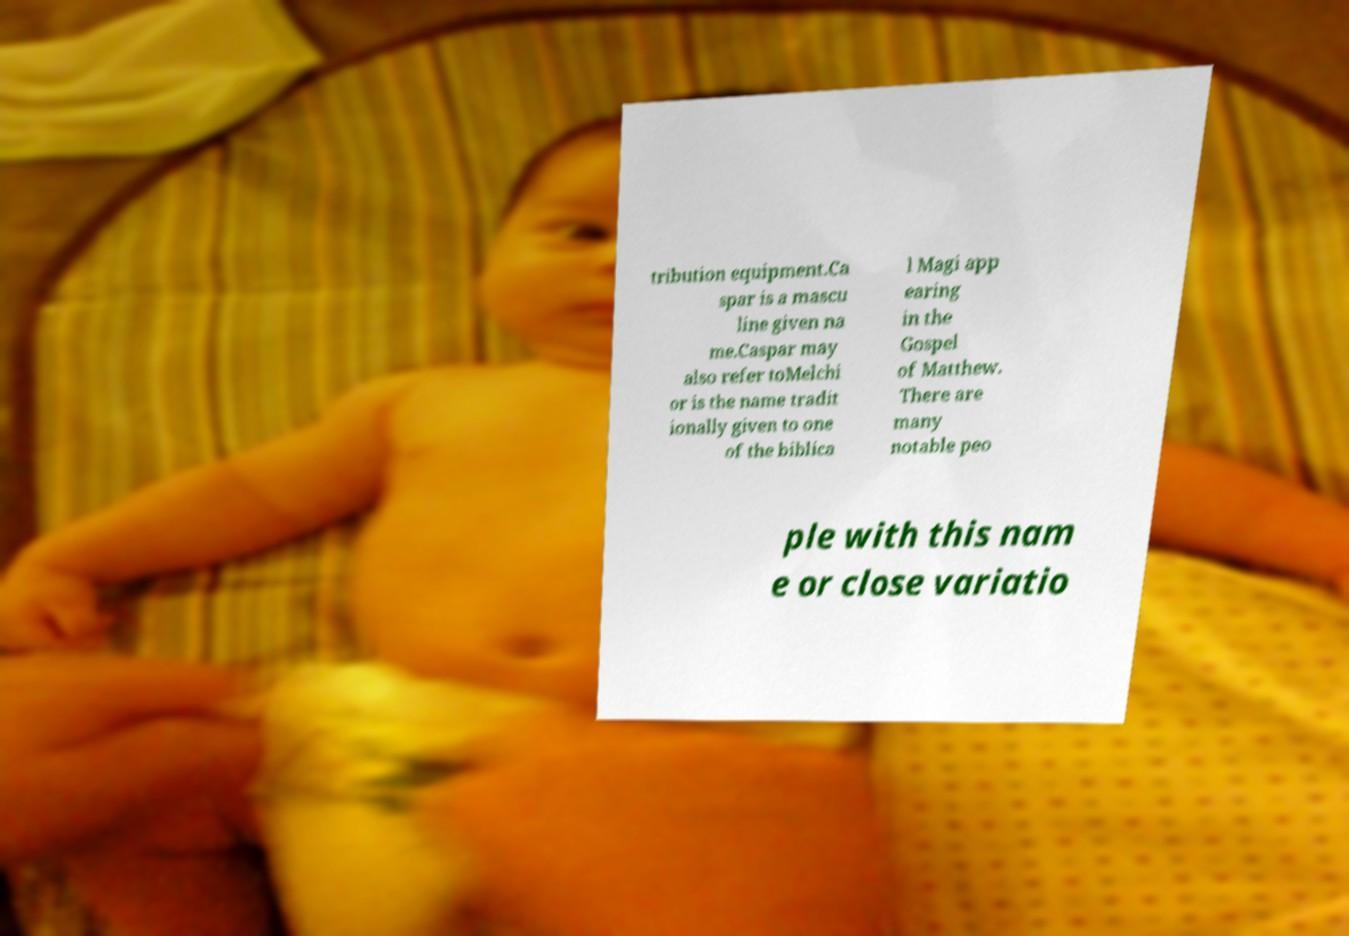For documentation purposes, I need the text within this image transcribed. Could you provide that? tribution equipment.Ca spar is a mascu line given na me.Caspar may also refer toMelchi or is the name tradit ionally given to one of the biblica l Magi app earing in the Gospel of Matthew. There are many notable peo ple with this nam e or close variatio 